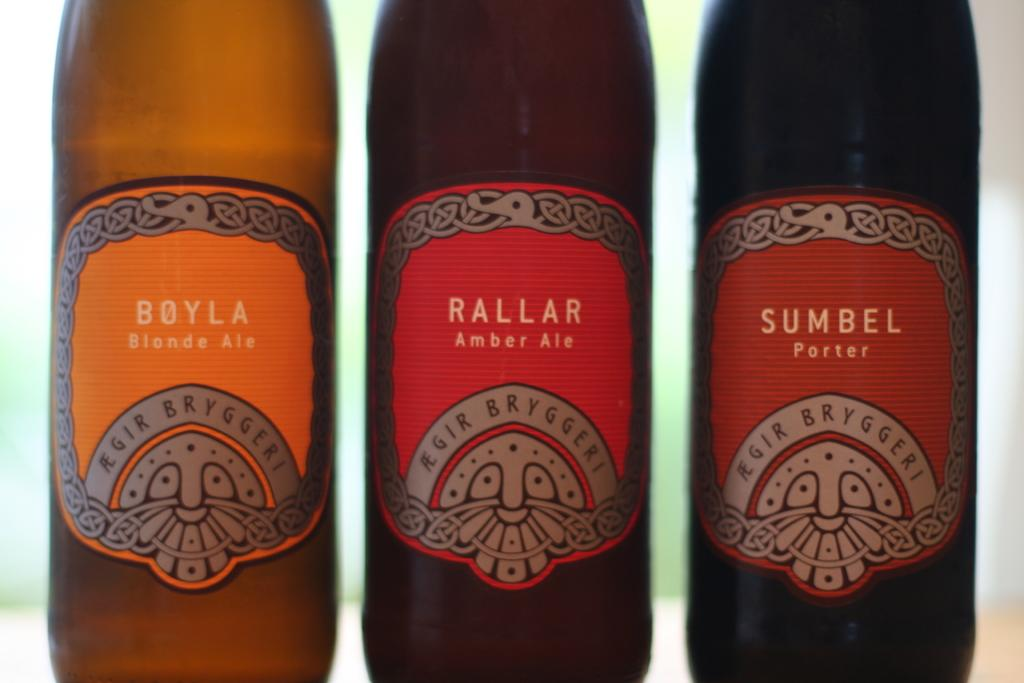<image>
Create a compact narrative representing the image presented. Three different types of beer, Amber, Blonde, and Porter, from the same manufacturer are standing beside one another, facing the same direction. 